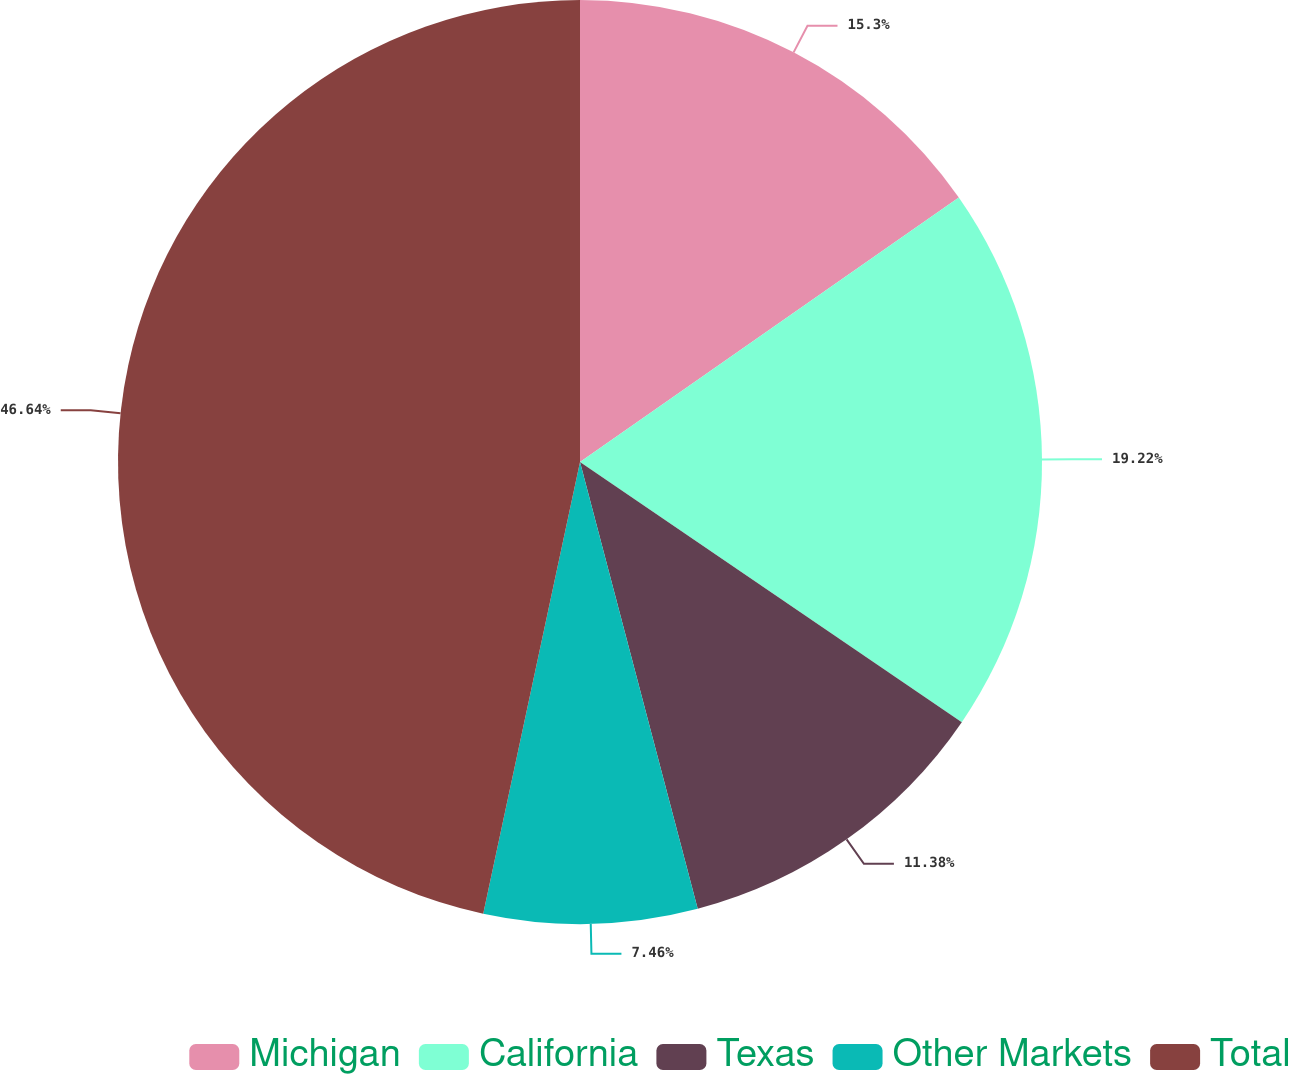<chart> <loc_0><loc_0><loc_500><loc_500><pie_chart><fcel>Michigan<fcel>California<fcel>Texas<fcel>Other Markets<fcel>Total<nl><fcel>15.3%<fcel>19.22%<fcel>11.38%<fcel>7.46%<fcel>46.64%<nl></chart> 